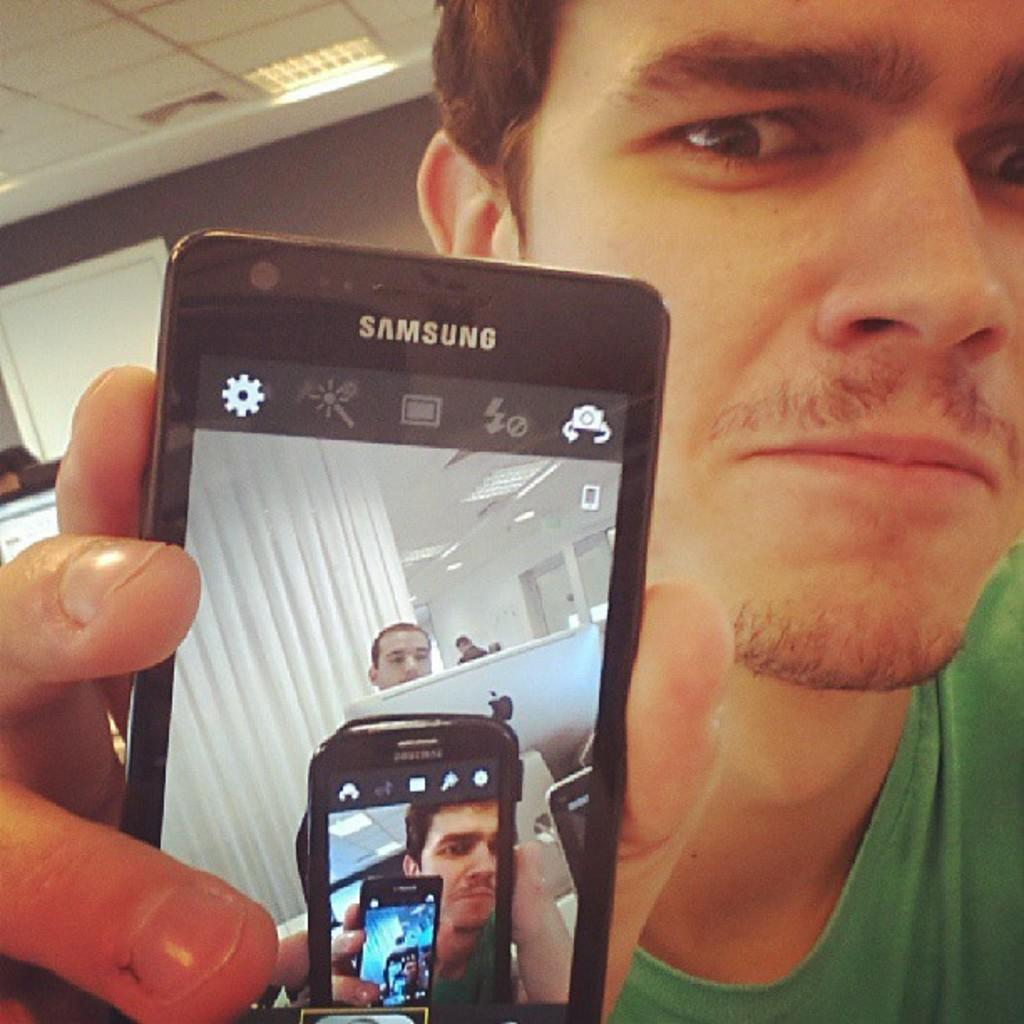<image>
Write a terse but informative summary of the picture. A man holding a cell phone by the Samsung brand 